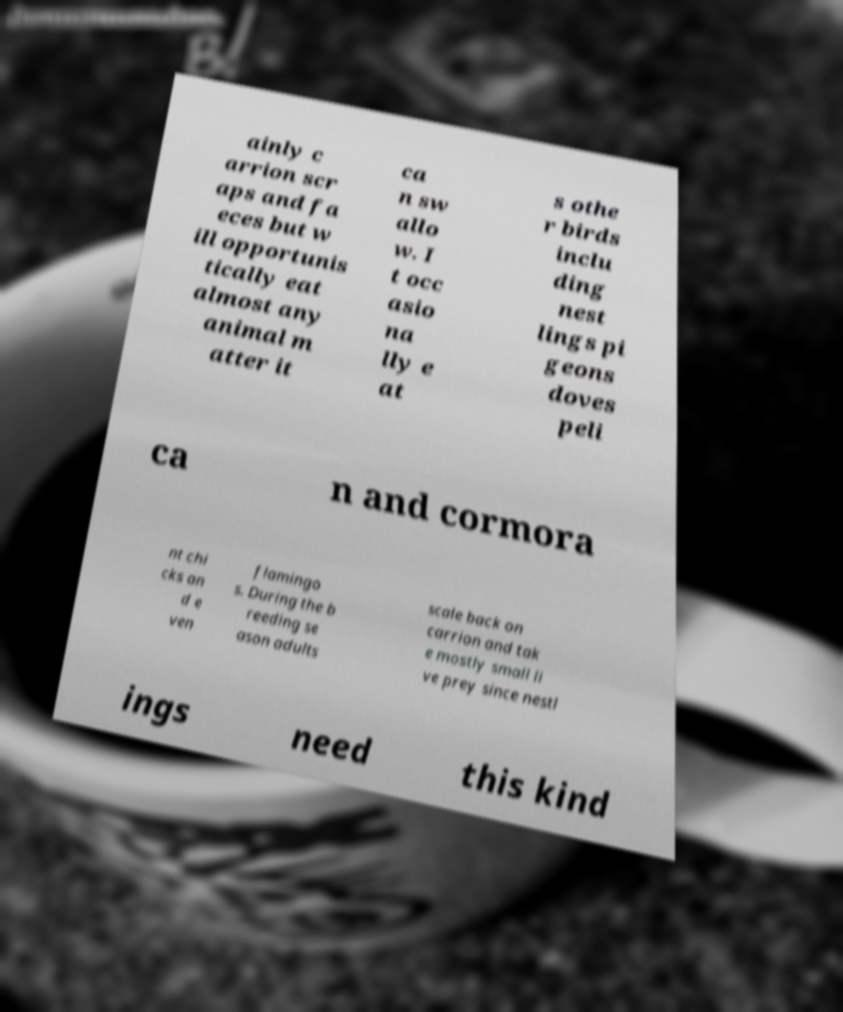I need the written content from this picture converted into text. Can you do that? ainly c arrion scr aps and fa eces but w ill opportunis tically eat almost any animal m atter it ca n sw allo w. I t occ asio na lly e at s othe r birds inclu ding nest lings pi geons doves peli ca n and cormora nt chi cks an d e ven flamingo s. During the b reeding se ason adults scale back on carrion and tak e mostly small li ve prey since nestl ings need this kind 